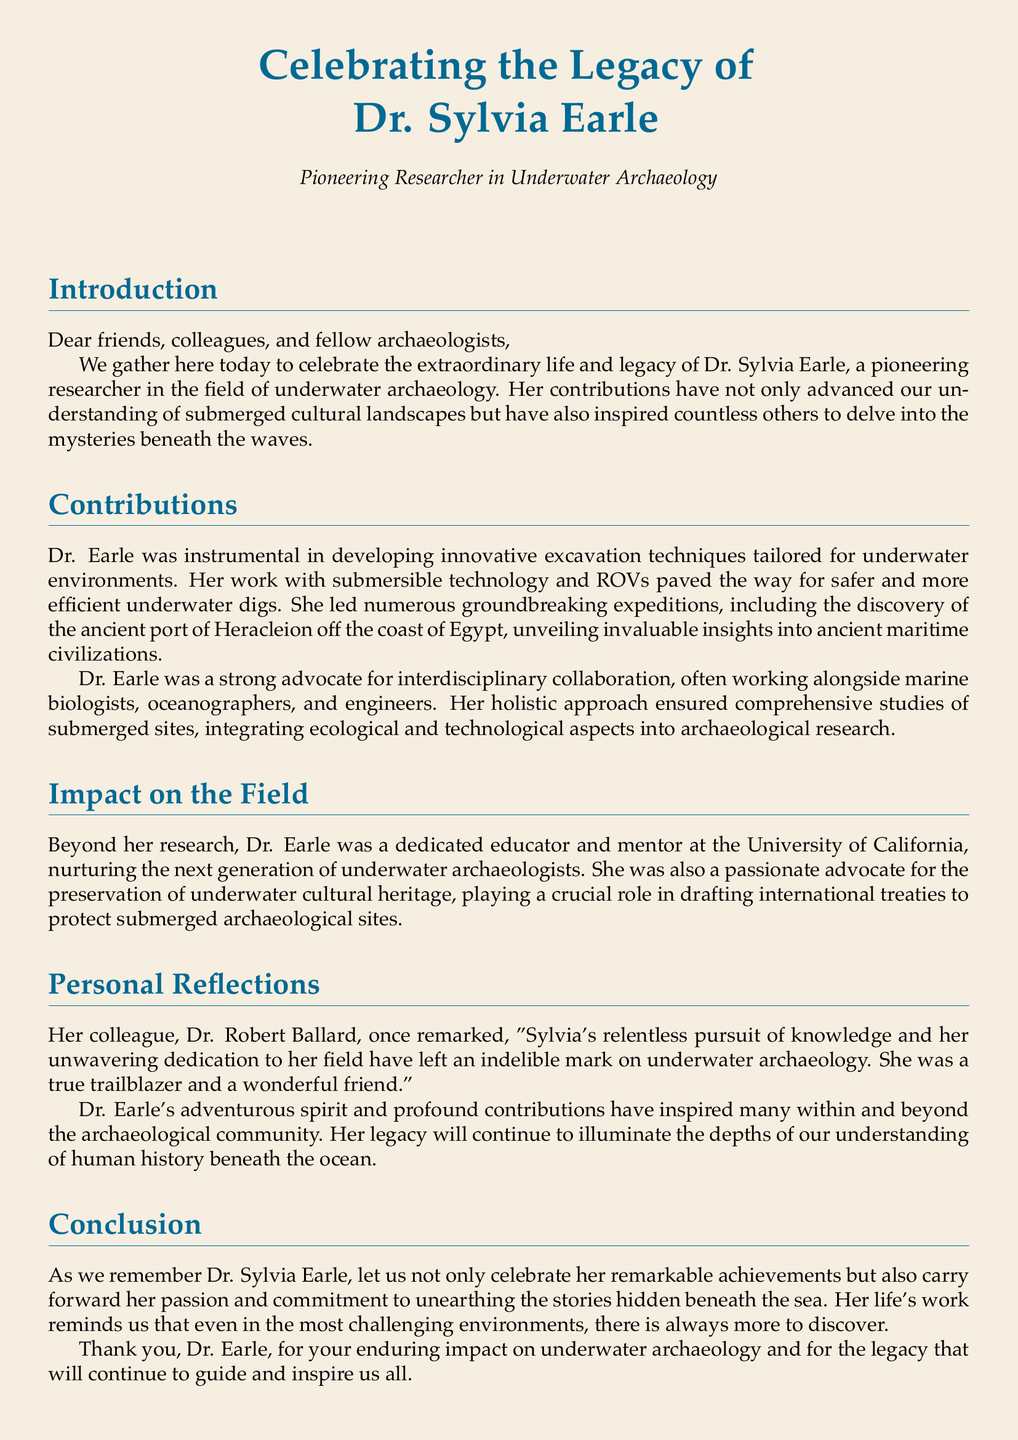What is the full name of the researcher being honored? The document states the full name of the researcher as Dr. Sylvia Earle.
Answer: Dr. Sylvia Earle What field was Dr. Earle a pioneer in? The document specifies that Dr. Earle was a pioneering researcher in underwater archaeology.
Answer: Underwater archaeology What significant site did Dr. Earle help discover? The document mentions the discovery of the ancient port of Heracleion off the coast of Egypt.
Answer: Heracleion Which university did Dr. Earle work at? The document indicates that Dr. Earle was a dedicated educator and mentor at the University of California.
Answer: University of California Who was Dr. Earle's colleague that made a remark about her? The document references Dr. Robert Ballard as her colleague who reflected on her legacy.
Answer: Dr. Robert Ballard What did Dr. Earle advocate for in addition to her research? The document states that Dr. Earle was a passionate advocate for the preservation of underwater cultural heritage.
Answer: Preservation of underwater cultural heritage What type of technology did Dr. Earle innovate in relation to underwater archaeology? The document describes her development of submersible technology and ROVs for underwater excavations.
Answer: Submersible technology and ROVs What is the overall theme of the document? The theme revolves around celebrating Dr. Earle's legacy and contributions to underwater archaeology.
Answer: Celebrating Dr. Earle's legacy What type of document is this? The document is a eulogy, which honors the life and contributions of an individual.
Answer: Eulogy 